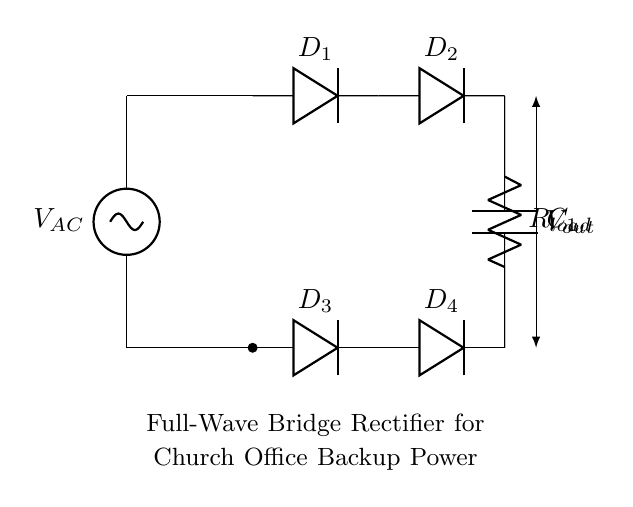what type of rectifier is used in this circuit? The circuit diagram shows a full-wave bridge rectifier, indicated by the four diodes arranged in a bridge configuration. This arrangement allows both halves of the AC input signal to contribute to the output voltage.
Answer: full-wave bridge rectifier how many diodes are in the circuit? The diagram clearly shows four diodes labeled D1, D2, D3, and D4, which make up the bridge rectifier circuit. Each diode conducts current in a specific direction during different phases of the AC cycle.
Answer: four diodes what is the purpose of the capacitor in this circuit? The capacitor, labeled C1, is used for smoothing the output voltage. It charges when the output voltage is at its peak and discharges during the gaps, thus reducing voltage fluctuations and providing a more stable DC output.
Answer: smoothing the output voltage what is the output voltage in relation to the AC voltage? The output voltage (Vout) will be approximately equal to the peak AC voltage minus the forward voltage drops across the diodes in the bridge rectifier. This relationship is crucial for knowing the efficiency of power conversion.
Answer: peak AC voltage minus diode drops why is a full-wave bridge rectifier preferred for backup power? A full-wave bridge rectifier is preferred for backup power because it utilizes both halves of the AC waveform, improving efficiency as it provides a higher average output voltage and greater overall power delivery compared to a half-wave rectifier. This is essential for maintaining reliable power supply to the church office during outages.
Answer: higher average output voltage 